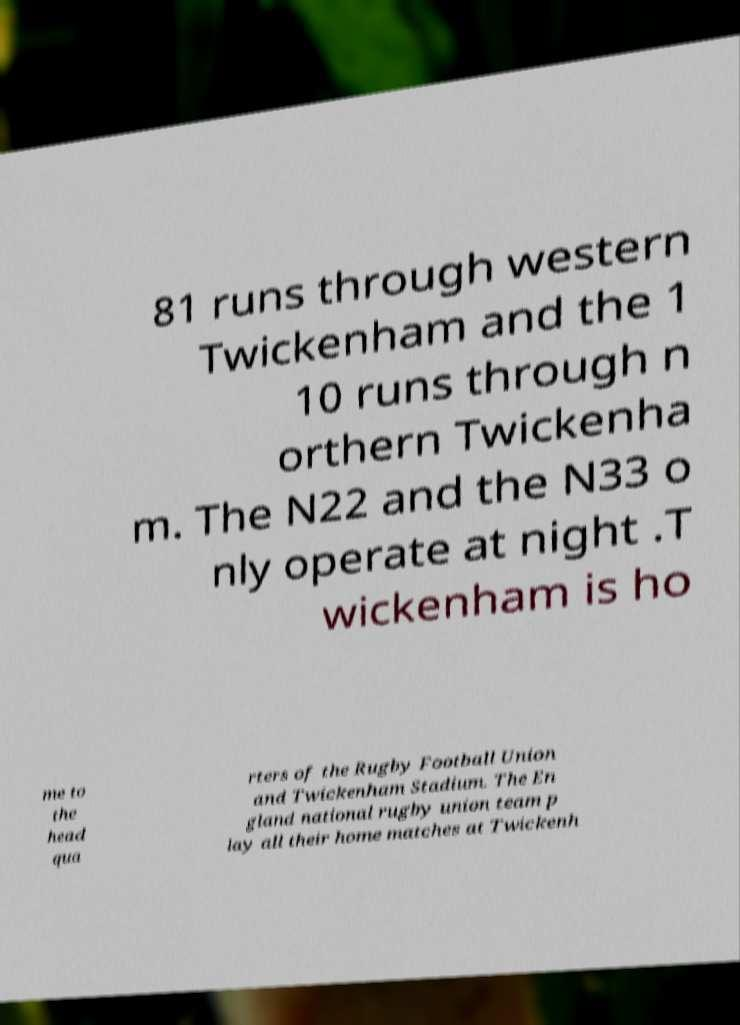For documentation purposes, I need the text within this image transcribed. Could you provide that? 81 runs through western Twickenham and the 1 10 runs through n orthern Twickenha m. The N22 and the N33 o nly operate at night .T wickenham is ho me to the head qua rters of the Rugby Football Union and Twickenham Stadium. The En gland national rugby union team p lay all their home matches at Twickenh 